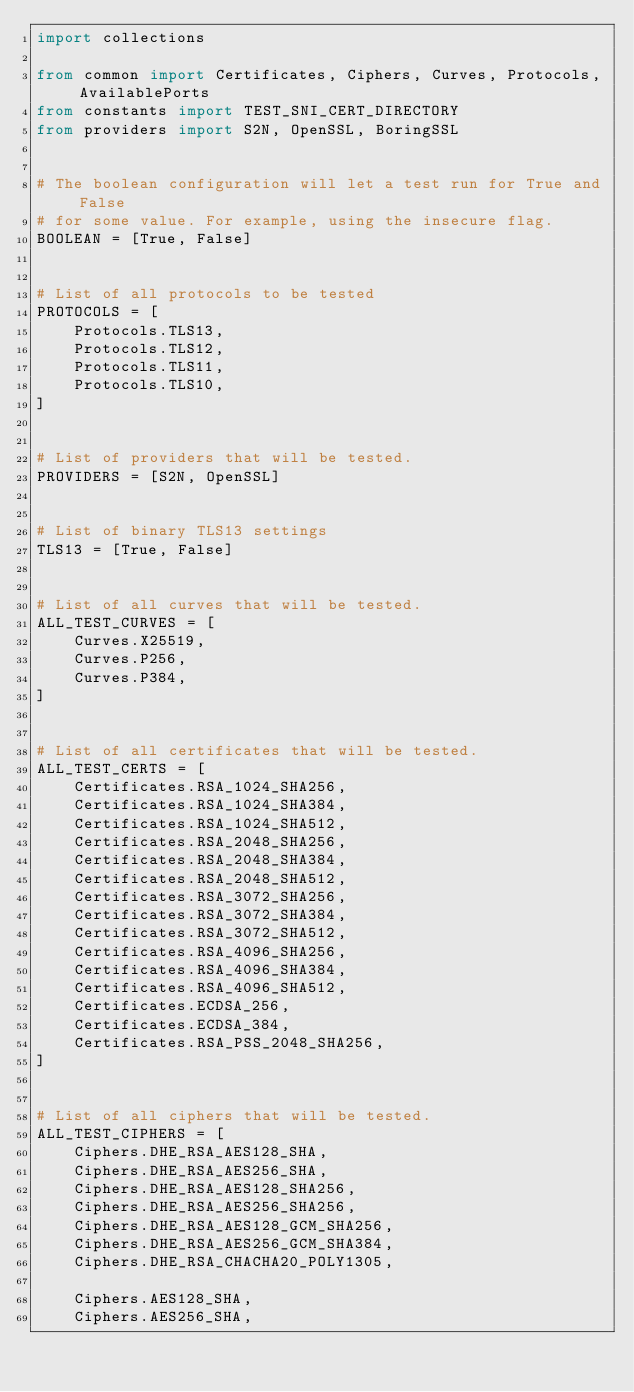Convert code to text. <code><loc_0><loc_0><loc_500><loc_500><_Python_>import collections

from common import Certificates, Ciphers, Curves, Protocols, AvailablePorts
from constants import TEST_SNI_CERT_DIRECTORY
from providers import S2N, OpenSSL, BoringSSL


# The boolean configuration will let a test run for True and False
# for some value. For example, using the insecure flag.
BOOLEAN = [True, False]


# List of all protocols to be tested
PROTOCOLS = [
    Protocols.TLS13,
    Protocols.TLS12,
    Protocols.TLS11,
    Protocols.TLS10,
]


# List of providers that will be tested.
PROVIDERS = [S2N, OpenSSL]


# List of binary TLS13 settings
TLS13 = [True, False]


# List of all curves that will be tested.
ALL_TEST_CURVES = [
    Curves.X25519,
    Curves.P256,
    Curves.P384,
]


# List of all certificates that will be tested.
ALL_TEST_CERTS = [
    Certificates.RSA_1024_SHA256,
    Certificates.RSA_1024_SHA384,
    Certificates.RSA_1024_SHA512,
    Certificates.RSA_2048_SHA256,
    Certificates.RSA_2048_SHA384,
    Certificates.RSA_2048_SHA512,
    Certificates.RSA_3072_SHA256,
    Certificates.RSA_3072_SHA384,
    Certificates.RSA_3072_SHA512,
    Certificates.RSA_4096_SHA256,
    Certificates.RSA_4096_SHA384,
    Certificates.RSA_4096_SHA512,
    Certificates.ECDSA_256,
    Certificates.ECDSA_384,
    Certificates.RSA_PSS_2048_SHA256,
]


# List of all ciphers that will be tested.
ALL_TEST_CIPHERS = [
    Ciphers.DHE_RSA_AES128_SHA,
    Ciphers.DHE_RSA_AES256_SHA,
    Ciphers.DHE_RSA_AES128_SHA256,
    Ciphers.DHE_RSA_AES256_SHA256,
    Ciphers.DHE_RSA_AES128_GCM_SHA256,
    Ciphers.DHE_RSA_AES256_GCM_SHA384,
    Ciphers.DHE_RSA_CHACHA20_POLY1305,

    Ciphers.AES128_SHA,
    Ciphers.AES256_SHA,</code> 